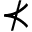Convert formula to latex. <formula><loc_0><loc_0><loc_500><loc_500>\nprec</formula> 